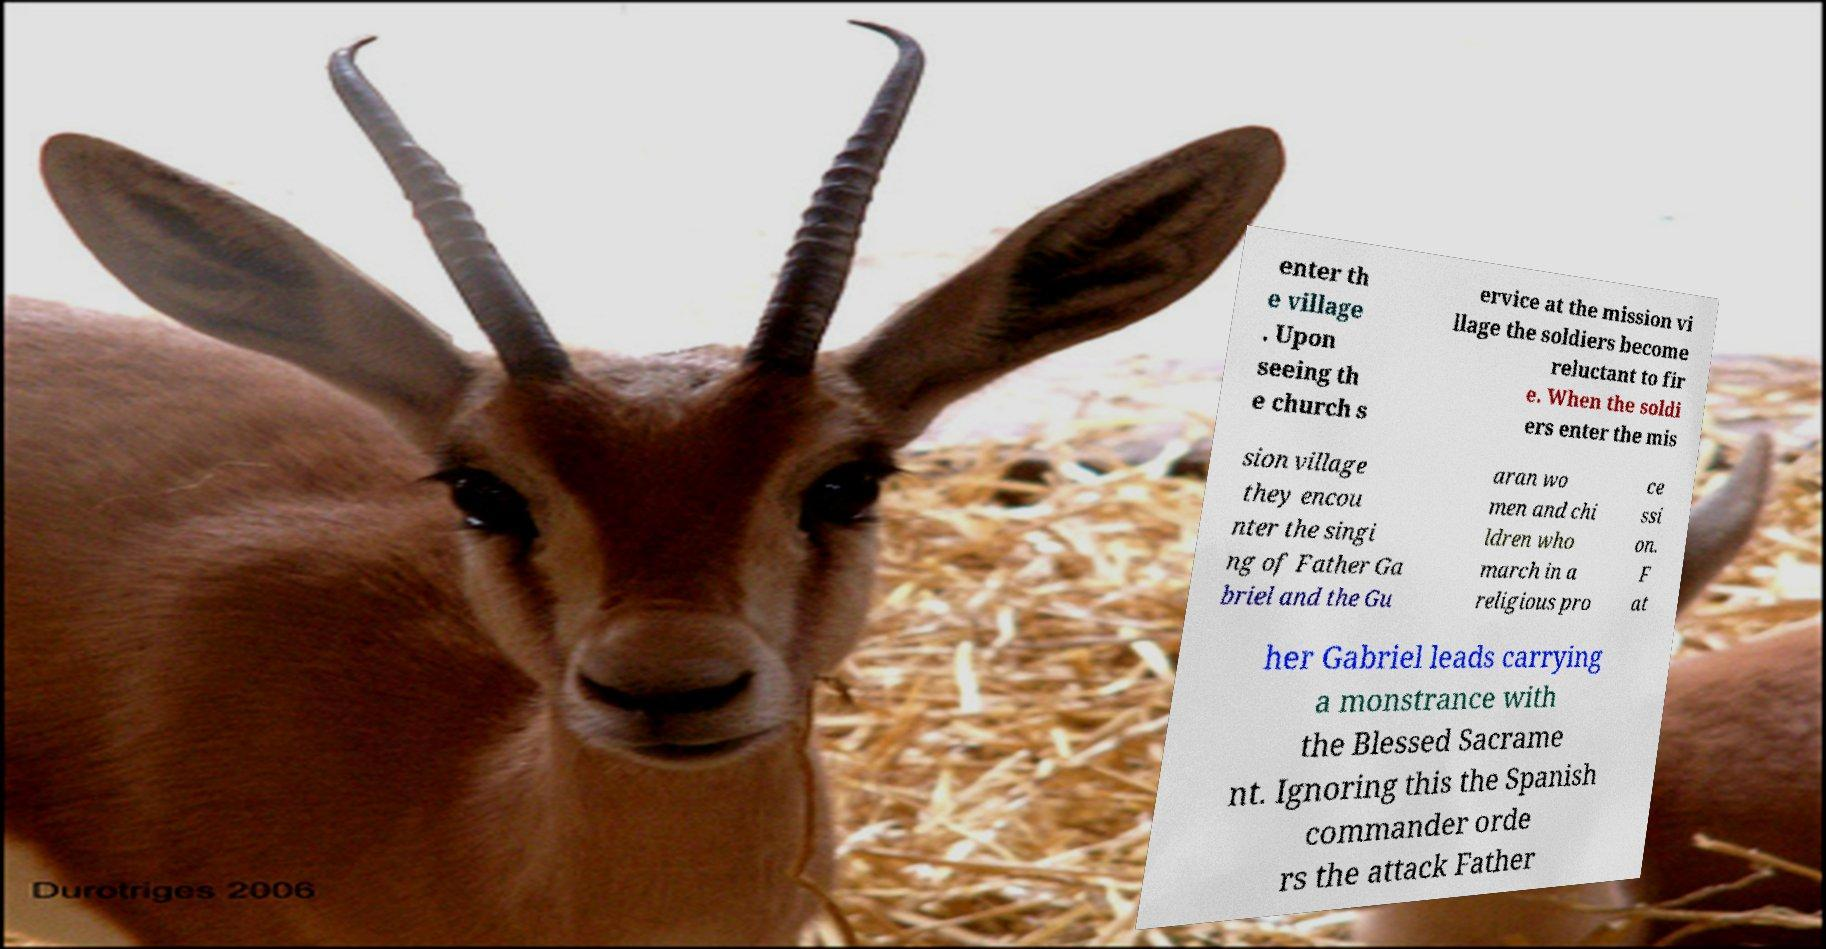There's text embedded in this image that I need extracted. Can you transcribe it verbatim? enter th e village . Upon seeing th e church s ervice at the mission vi llage the soldiers become reluctant to fir e. When the soldi ers enter the mis sion village they encou nter the singi ng of Father Ga briel and the Gu aran wo men and chi ldren who march in a religious pro ce ssi on. F at her Gabriel leads carrying a monstrance with the Blessed Sacrame nt. Ignoring this the Spanish commander orde rs the attack Father 